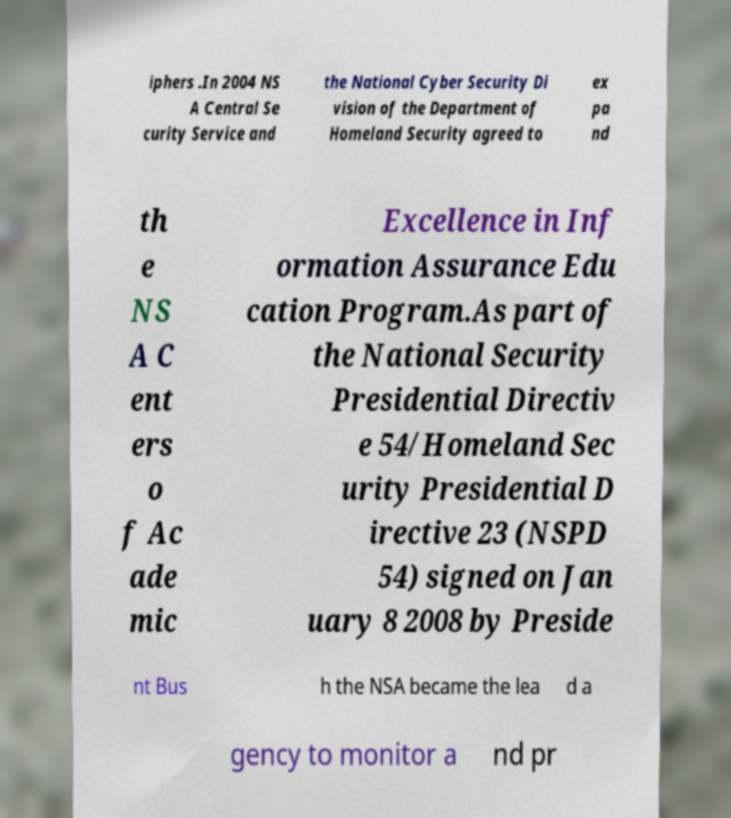I need the written content from this picture converted into text. Can you do that? iphers .In 2004 NS A Central Se curity Service and the National Cyber Security Di vision of the Department of Homeland Security agreed to ex pa nd th e NS A C ent ers o f Ac ade mic Excellence in Inf ormation Assurance Edu cation Program.As part of the National Security Presidential Directiv e 54/Homeland Sec urity Presidential D irective 23 (NSPD 54) signed on Jan uary 8 2008 by Preside nt Bus h the NSA became the lea d a gency to monitor a nd pr 